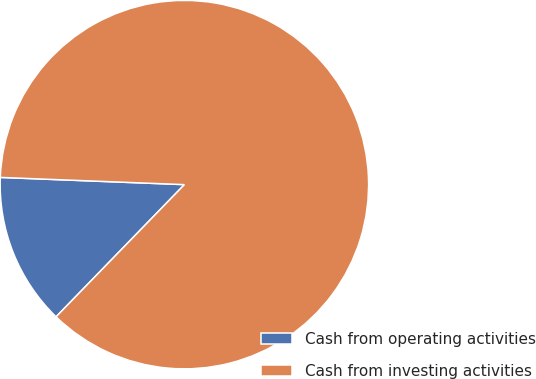Convert chart. <chart><loc_0><loc_0><loc_500><loc_500><pie_chart><fcel>Cash from operating activities<fcel>Cash from investing activities<nl><fcel>13.36%<fcel>86.64%<nl></chart> 